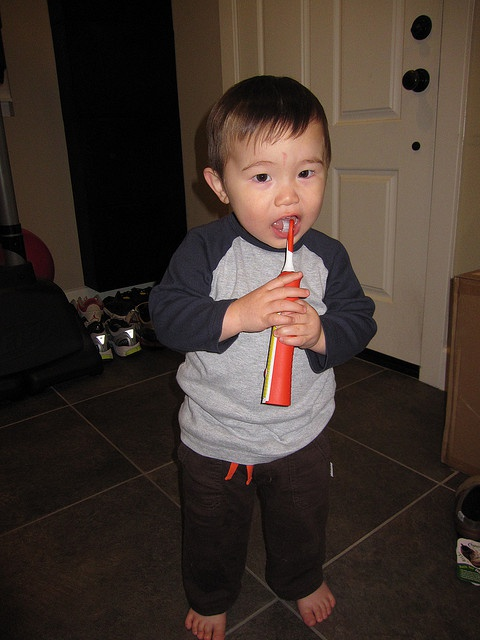Describe the objects in this image and their specific colors. I can see people in black, darkgray, tan, and brown tones and toothbrush in black, salmon, red, and white tones in this image. 